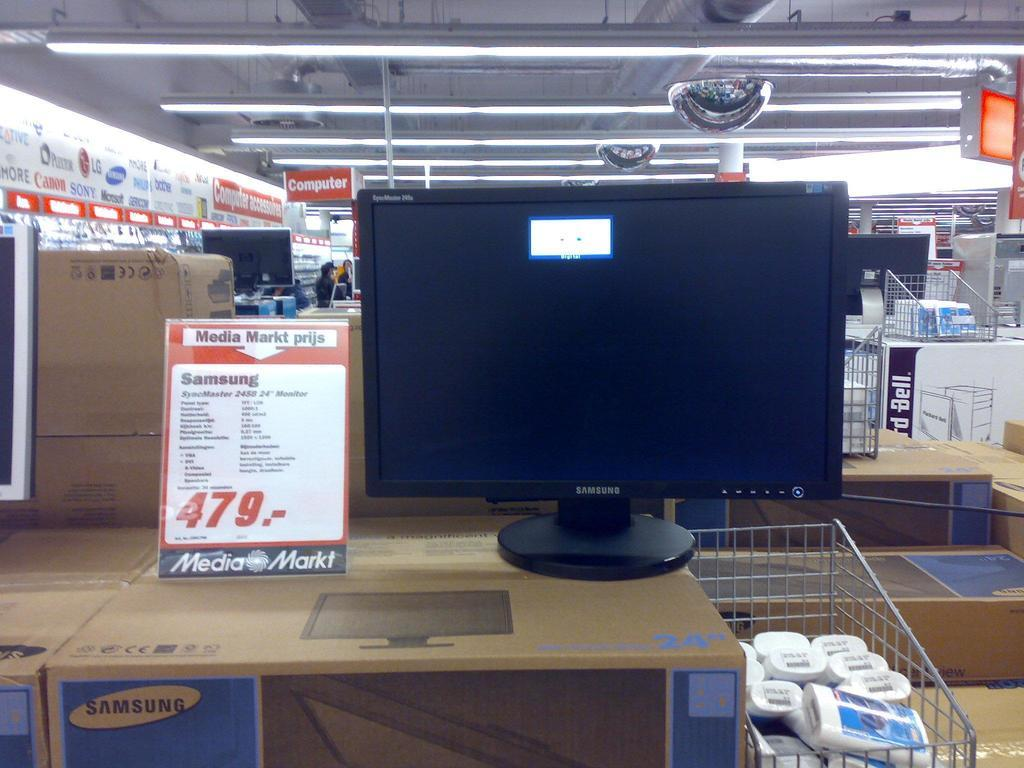<image>
Render a clear and concise summary of the photo. A Samsung monitor displayed on top of several boxes in a store. 